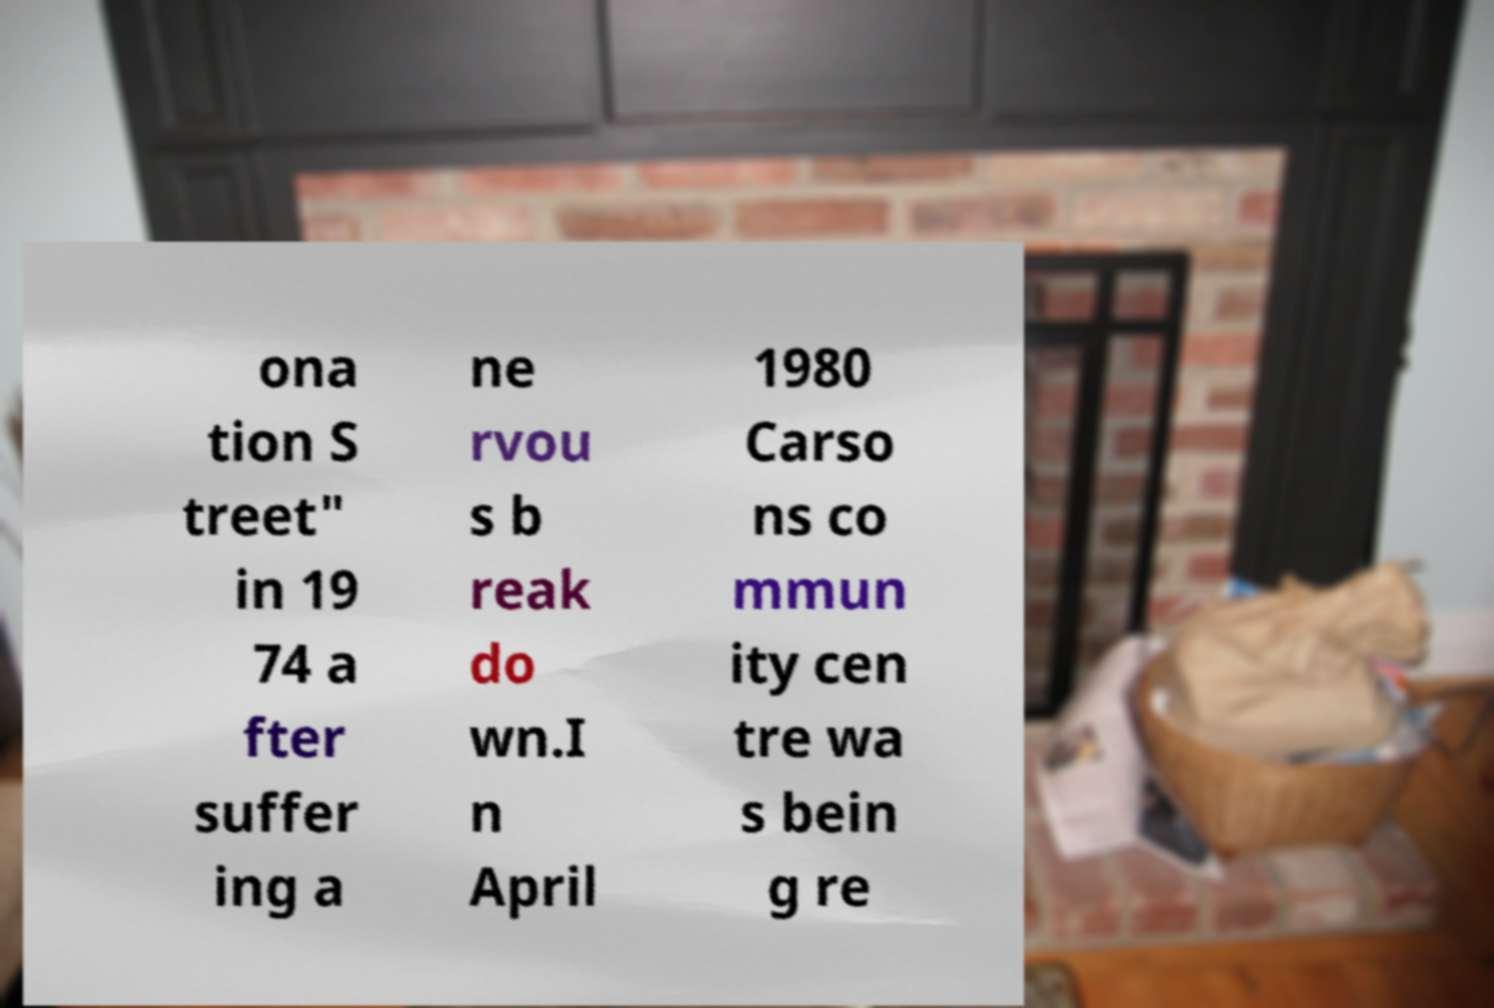What messages or text are displayed in this image? I need them in a readable, typed format. ona tion S treet" in 19 74 a fter suffer ing a ne rvou s b reak do wn.I n April 1980 Carso ns co mmun ity cen tre wa s bein g re 